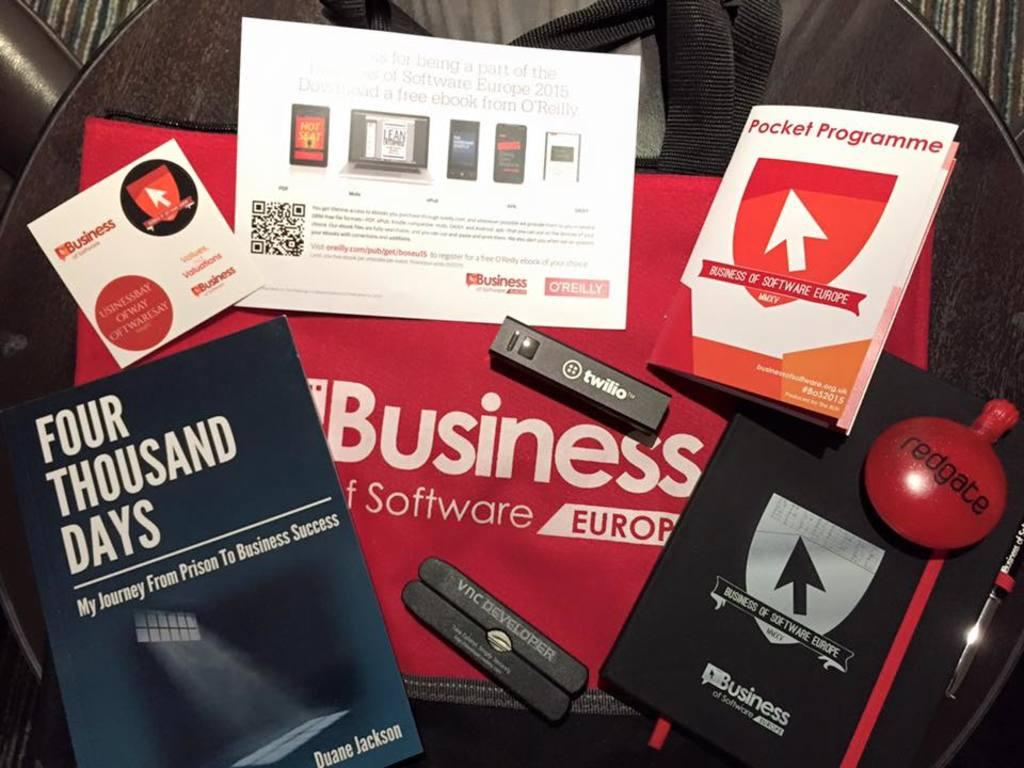<image>
Write a terse but informative summary of the picture. One of the many items is a book about becoming successful after prison. 